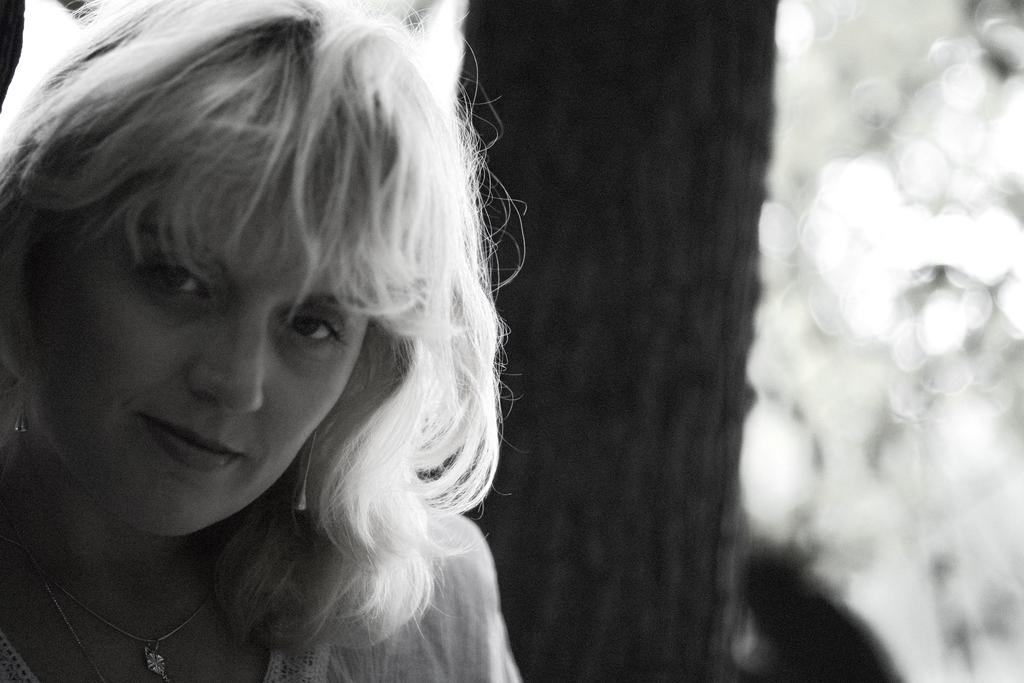Who is present in the image? There is a woman in the image. What is the woman doing in the image? The woman is smiling in the image. What is the color scheme of the image? The image is black and white. What type of hook can be seen in the woman's hand in the image? There is no hook present in the image; the woman is simply smiling. 